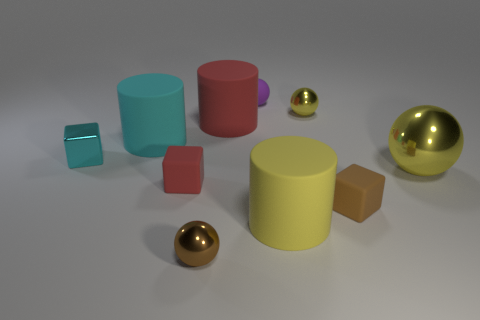What is the shape of the big thing that is the same color as the small shiny block?
Your answer should be very brief. Cylinder. What number of other things are there of the same size as the cyan metal thing?
Make the answer very short. 5. Is the big yellow thing that is in front of the red matte cube made of the same material as the red cylinder?
Offer a terse response. Yes. How many other things are there of the same color as the big ball?
Your response must be concise. 2. What number of other objects are the same shape as the tiny yellow shiny object?
Offer a very short reply. 3. There is a yellow shiny object that is behind the large red cylinder; is its shape the same as the tiny brown thing to the right of the red cylinder?
Offer a terse response. No. Are there an equal number of purple rubber things that are to the left of the small purple rubber sphere and yellow shiny things that are in front of the brown shiny sphere?
Your answer should be compact. Yes. There is a large matte object that is in front of the red rubber thing that is in front of the big object that is to the left of the red matte cube; what is its shape?
Keep it short and to the point. Cylinder. Is the red object in front of the large red cylinder made of the same material as the big cylinder in front of the small brown rubber cube?
Your answer should be very brief. Yes. The yellow thing that is behind the red cylinder has what shape?
Keep it short and to the point. Sphere. 